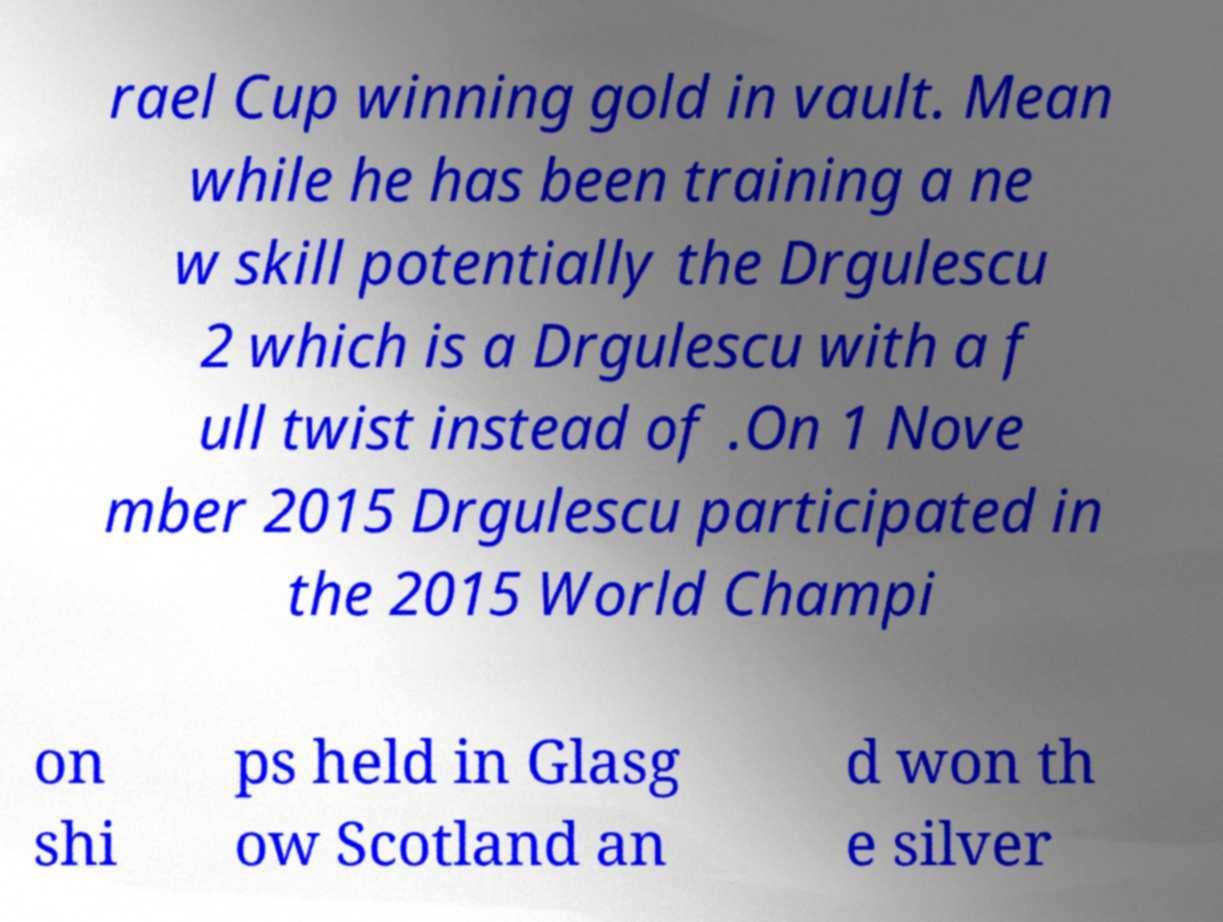There's text embedded in this image that I need extracted. Can you transcribe it verbatim? rael Cup winning gold in vault. Mean while he has been training a ne w skill potentially the Drgulescu 2 which is a Drgulescu with a f ull twist instead of .On 1 Nove mber 2015 Drgulescu participated in the 2015 World Champi on shi ps held in Glasg ow Scotland an d won th e silver 